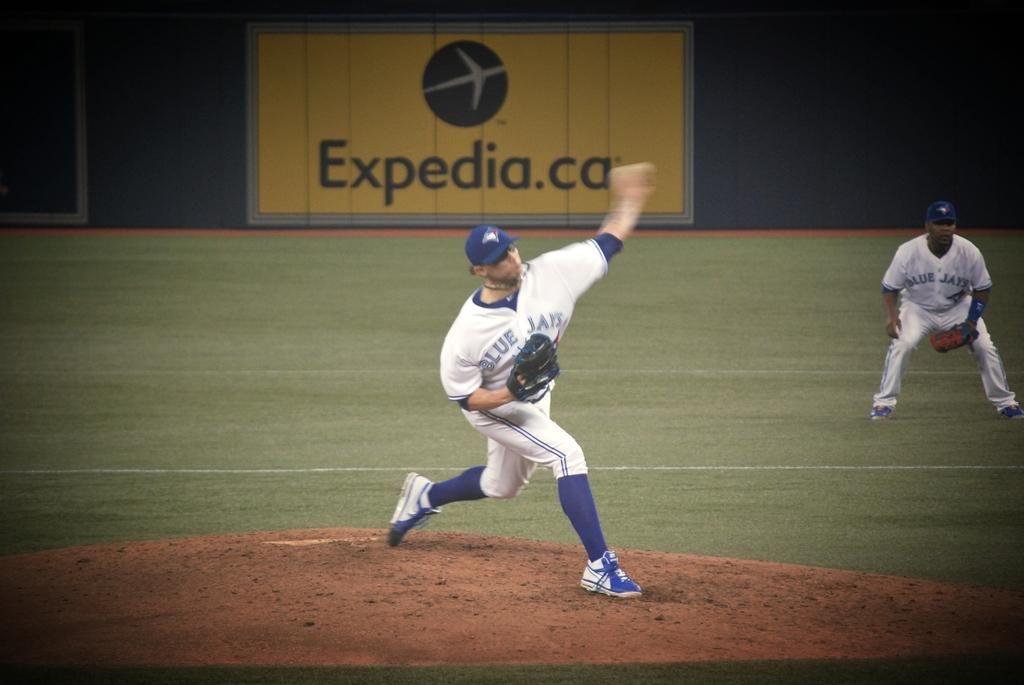<image>
Provide a brief description of the given image. A Blue Jays pitcher throws the ball in front of an ad for Expedia. 